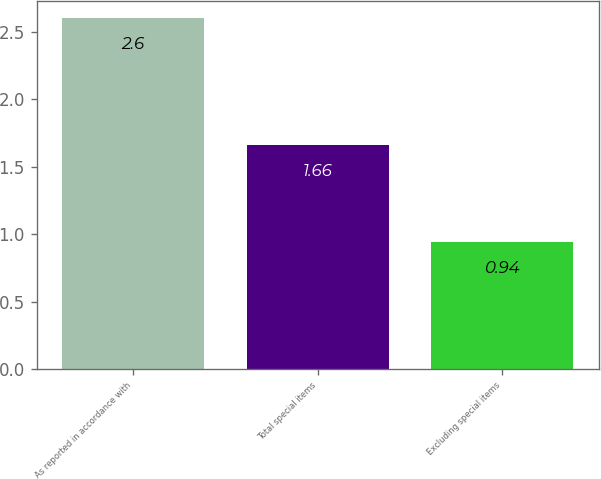Convert chart to OTSL. <chart><loc_0><loc_0><loc_500><loc_500><bar_chart><fcel>As reported in accordance with<fcel>Total special items<fcel>Excluding special items<nl><fcel>2.6<fcel>1.66<fcel>0.94<nl></chart> 